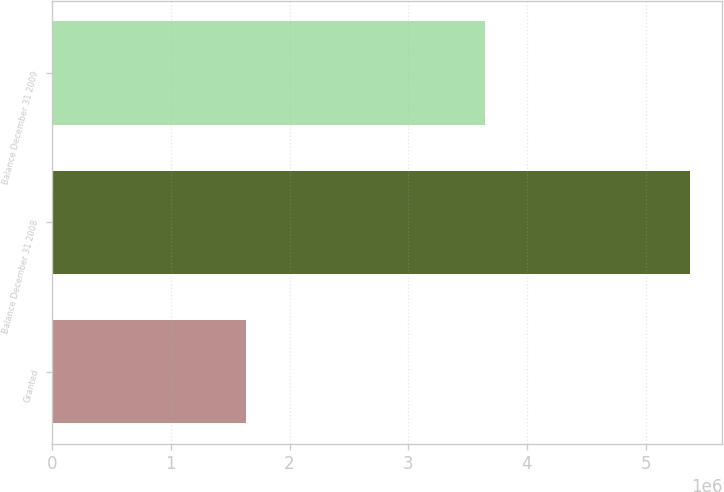<chart> <loc_0><loc_0><loc_500><loc_500><bar_chart><fcel>Granted<fcel>Balance December 31 2008<fcel>Balance December 31 2009<nl><fcel>1.63242e+06<fcel>5.37493e+06<fcel>3.6428e+06<nl></chart> 